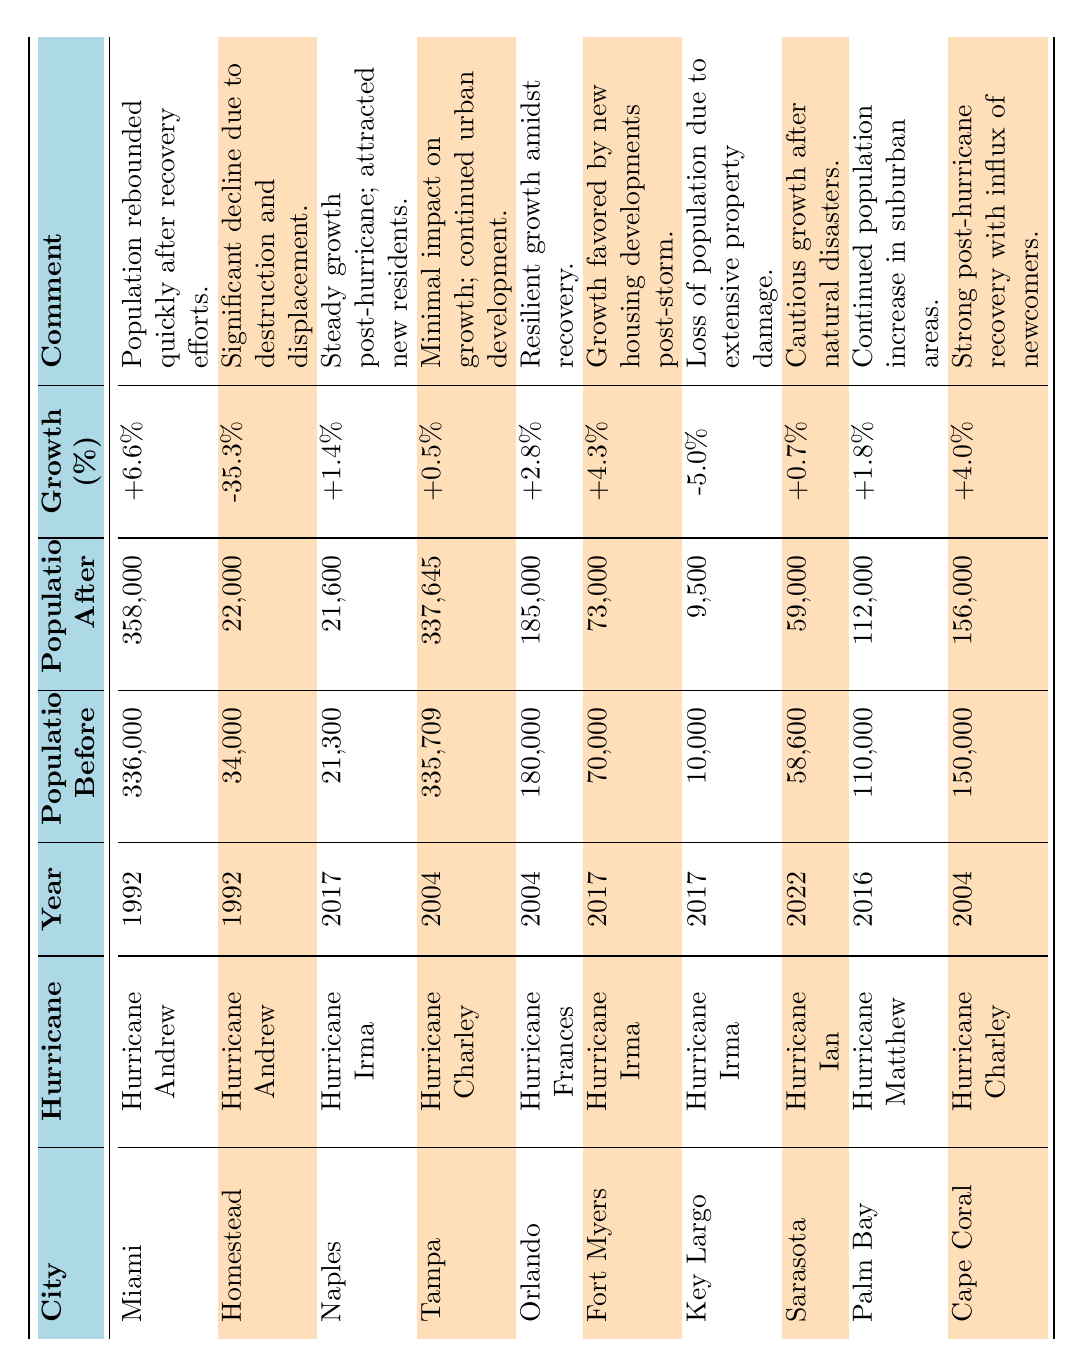What was the population of Miami before Hurricane Andrew? According to the table, Miami's population before Hurricane Andrew in 1992 was listed as 336,000.
Answer: 336,000 Which city experienced the largest percentage decline in population after Hurricane Andrew? The table shows Homestead's population declined from 34,000 to 22,000, resulting in a -35.3% change, which is the highest decline among all listed cities.
Answer: Homestead What was the total population change in Tampa after Hurricane Charley? The population in Tampa increased from 335,709 to 337,645, so the total change is 337,645 - 335,709 = 1,936.
Answer: 1,936 Did Sarasota experience growth after Hurricane Ian? The table indicates that Sarasota's population grew from 58,600 to 59,000, which confirms that there was growth.
Answer: Yes What is the average growth percentage for Naples, Fort Myers, and Cape Coral combined? The growth percentages for Naples (+1.4%), Fort Myers (+4.3%), and Cape Coral (+4.0%) add up to 9.7%, and the average is 9.7% / 3 = 3.23%.
Answer: 3.23% Which hurricane led to a population loss in Key Largo? The data shows that Key Largo lost population after Hurricane Irma in 2017, with a decline from 10,000 to 9,500.
Answer: Hurricane Irma What was the population of Cap Coral after Hurricane Charley? The table clearly states that Cape Coral's population after Hurricane Charley in 2004 was 156,000.
Answer: 156,000 Which city had the smallest population increase after its associated hurricane? From the table, Tampa had the smallest increase at +0.5%, the least among all cities listed.
Answer: Tampa How does the population of Fort Myers compare to Naples after their respective hurricanes? Fort Myers had a population of 73,000 after Hurricane Irma, while Naples had a population of 21,600 after Hurricane Irma. Fort Myers had a significantly larger population than Naples post-hurricane.
Answer: Fort Myers had a larger population What is the trend in population changes for cities after hurricanes in Florida? Analyzing the table, we can see varied trends: some cities experienced growth while others had declines, indicating mixed outcomes after hurricanes. For example, Miami and Fort Myers saw growth while Homestead and Key Largo experienced population losses.
Answer: Mixed outcomes 